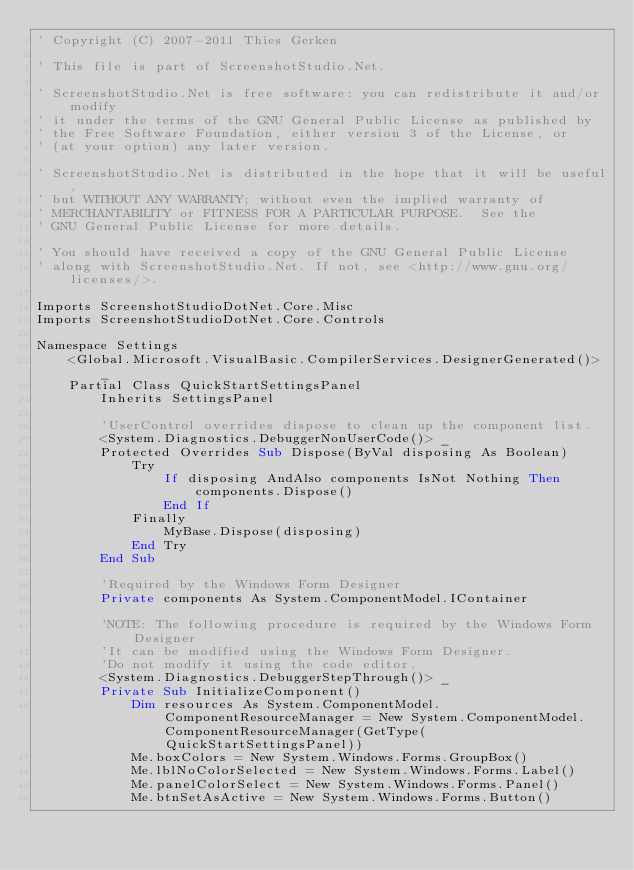<code> <loc_0><loc_0><loc_500><loc_500><_VisualBasic_>' Copyright (C) 2007-2011 Thies Gerken

' This file is part of ScreenshotStudio.Net.

' ScreenshotStudio.Net is free software: you can redistribute it and/or modify
' it under the terms of the GNU General Public License as published by
' the Free Software Foundation, either version 3 of the License, or
' (at your option) any later version.

' ScreenshotStudio.Net is distributed in the hope that it will be useful,
' but WITHOUT ANY WARRANTY; without even the implied warranty of
' MERCHANTABILITY or FITNESS FOR A PARTICULAR PURPOSE.  See the
' GNU General Public License for more details.

' You should have received a copy of the GNU General Public License
' along with ScreenshotStudio.Net. If not, see <http://www.gnu.org/licenses/>.

Imports ScreenshotStudioDotNet.Core.Misc
Imports ScreenshotStudioDotNet.Core.Controls

Namespace Settings
    <Global.Microsoft.VisualBasic.CompilerServices.DesignerGenerated()> _
    Partial Class QuickStartSettingsPanel
        Inherits SettingsPanel

        'UserControl overrides dispose to clean up the component list.
        <System.Diagnostics.DebuggerNonUserCode()> _
        Protected Overrides Sub Dispose(ByVal disposing As Boolean)
            Try
                If disposing AndAlso components IsNot Nothing Then
                    components.Dispose()
                End If
            Finally
                MyBase.Dispose(disposing)
            End Try
        End Sub

        'Required by the Windows Form Designer
        Private components As System.ComponentModel.IContainer

        'NOTE: The following procedure is required by the Windows Form Designer
        'It can be modified using the Windows Form Designer.  
        'Do not modify it using the code editor.
        <System.Diagnostics.DebuggerStepThrough()> _
        Private Sub InitializeComponent()
            Dim resources As System.ComponentModel.ComponentResourceManager = New System.ComponentModel.ComponentResourceManager(GetType(QuickStartSettingsPanel))
            Me.boxColors = New System.Windows.Forms.GroupBox()
            Me.lblNoColorSelected = New System.Windows.Forms.Label()
            Me.panelColorSelect = New System.Windows.Forms.Panel()
            Me.btnSetAsActive = New System.Windows.Forms.Button()</code> 